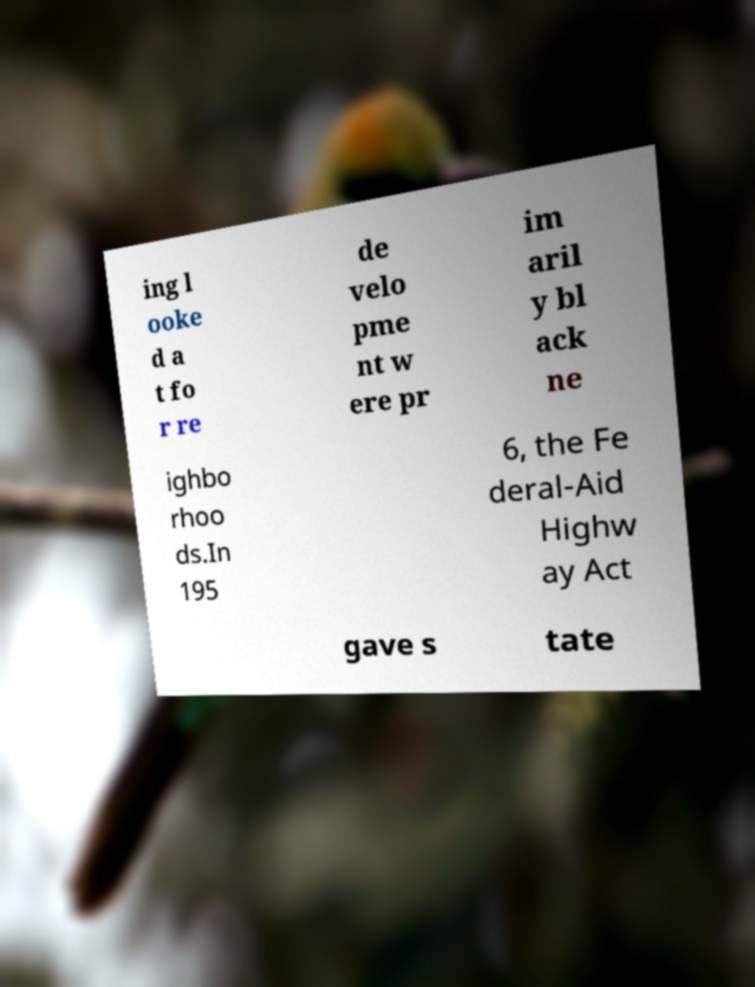Can you read and provide the text displayed in the image?This photo seems to have some interesting text. Can you extract and type it out for me? ing l ooke d a t fo r re de velo pme nt w ere pr im aril y bl ack ne ighbo rhoo ds.In 195 6, the Fe deral-Aid Highw ay Act gave s tate 